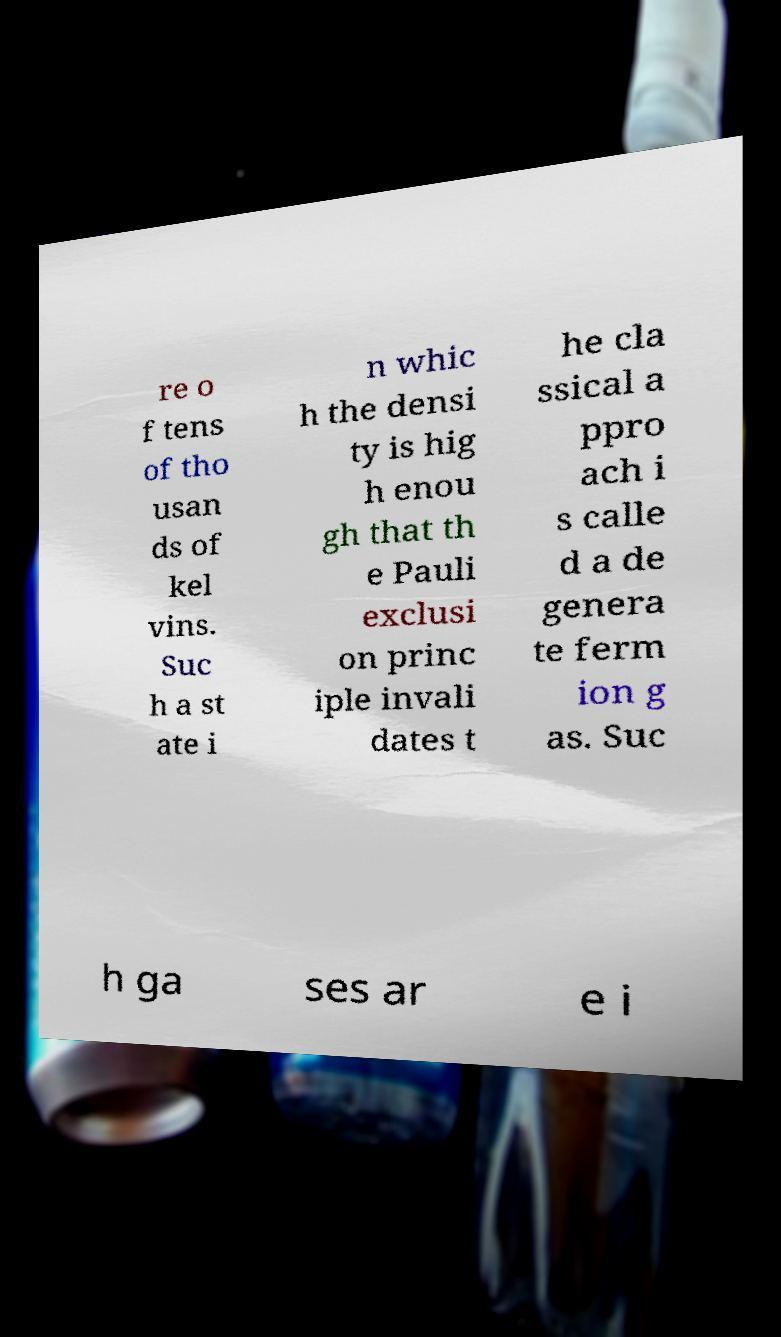Please identify and transcribe the text found in this image. re o f tens of tho usan ds of kel vins. Suc h a st ate i n whic h the densi ty is hig h enou gh that th e Pauli exclusi on princ iple invali dates t he cla ssical a ppro ach i s calle d a de genera te ferm ion g as. Suc h ga ses ar e i 